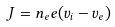<formula> <loc_0><loc_0><loc_500><loc_500>J = { n } _ { e } { e ( } v _ { i } - v _ { e } { ) }</formula> 